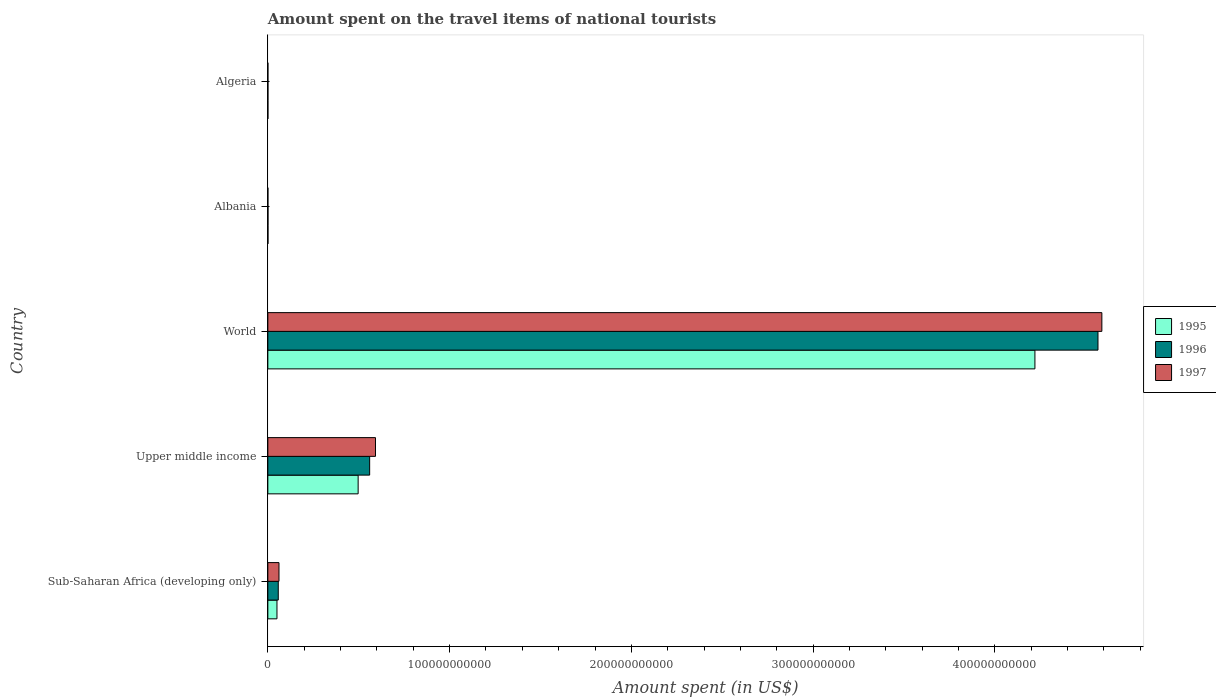How many groups of bars are there?
Provide a short and direct response. 5. Are the number of bars per tick equal to the number of legend labels?
Provide a short and direct response. Yes. What is the label of the 4th group of bars from the top?
Offer a very short reply. Upper middle income. What is the amount spent on the travel items of national tourists in 1995 in Sub-Saharan Africa (developing only)?
Provide a short and direct response. 5.02e+09. Across all countries, what is the maximum amount spent on the travel items of national tourists in 1996?
Make the answer very short. 4.57e+11. Across all countries, what is the minimum amount spent on the travel items of national tourists in 1997?
Make the answer very short. 2.70e+07. In which country was the amount spent on the travel items of national tourists in 1997 minimum?
Keep it short and to the point. Albania. What is the total amount spent on the travel items of national tourists in 1997 in the graph?
Ensure brevity in your answer.  5.24e+11. What is the difference between the amount spent on the travel items of national tourists in 1997 in Albania and that in Upper middle income?
Offer a very short reply. -5.92e+1. What is the difference between the amount spent on the travel items of national tourists in 1997 in Algeria and the amount spent on the travel items of national tourists in 1995 in Sub-Saharan Africa (developing only)?
Offer a very short reply. -4.99e+09. What is the average amount spent on the travel items of national tourists in 1997 per country?
Give a very brief answer. 1.05e+11. What is the difference between the amount spent on the travel items of national tourists in 1996 and amount spent on the travel items of national tourists in 1997 in Sub-Saharan Africa (developing only)?
Give a very brief answer. -4.02e+08. What is the ratio of the amount spent on the travel items of national tourists in 1996 in Algeria to that in Sub-Saharan Africa (developing only)?
Keep it short and to the point. 0.01. What is the difference between the highest and the second highest amount spent on the travel items of national tourists in 1995?
Your response must be concise. 3.72e+11. What is the difference between the highest and the lowest amount spent on the travel items of national tourists in 1996?
Make the answer very short. 4.57e+11. What does the 3rd bar from the top in Algeria represents?
Ensure brevity in your answer.  1995. Is it the case that in every country, the sum of the amount spent on the travel items of national tourists in 1997 and amount spent on the travel items of national tourists in 1996 is greater than the amount spent on the travel items of national tourists in 1995?
Give a very brief answer. Yes. How many bars are there?
Give a very brief answer. 15. Are all the bars in the graph horizontal?
Your answer should be very brief. Yes. How many countries are there in the graph?
Offer a terse response. 5. What is the difference between two consecutive major ticks on the X-axis?
Your answer should be compact. 1.00e+11. Are the values on the major ticks of X-axis written in scientific E-notation?
Ensure brevity in your answer.  No. Does the graph contain any zero values?
Your answer should be very brief. No. Does the graph contain grids?
Provide a short and direct response. No. How many legend labels are there?
Provide a short and direct response. 3. How are the legend labels stacked?
Your answer should be very brief. Vertical. What is the title of the graph?
Provide a succinct answer. Amount spent on the travel items of national tourists. Does "1995" appear as one of the legend labels in the graph?
Offer a very short reply. Yes. What is the label or title of the X-axis?
Your answer should be very brief. Amount spent (in US$). What is the label or title of the Y-axis?
Provide a succinct answer. Country. What is the Amount spent (in US$) of 1995 in Sub-Saharan Africa (developing only)?
Provide a short and direct response. 5.02e+09. What is the Amount spent (in US$) in 1996 in Sub-Saharan Africa (developing only)?
Give a very brief answer. 5.73e+09. What is the Amount spent (in US$) of 1997 in Sub-Saharan Africa (developing only)?
Your answer should be very brief. 6.13e+09. What is the Amount spent (in US$) in 1995 in Upper middle income?
Ensure brevity in your answer.  4.97e+1. What is the Amount spent (in US$) in 1996 in Upper middle income?
Ensure brevity in your answer.  5.60e+1. What is the Amount spent (in US$) of 1997 in Upper middle income?
Offer a very short reply. 5.92e+1. What is the Amount spent (in US$) in 1995 in World?
Provide a succinct answer. 4.22e+11. What is the Amount spent (in US$) in 1996 in World?
Make the answer very short. 4.57e+11. What is the Amount spent (in US$) of 1997 in World?
Provide a short and direct response. 4.59e+11. What is the Amount spent (in US$) in 1995 in Albania?
Provide a succinct answer. 6.50e+07. What is the Amount spent (in US$) of 1996 in Albania?
Your answer should be very brief. 7.70e+07. What is the Amount spent (in US$) in 1997 in Albania?
Offer a terse response. 2.70e+07. What is the Amount spent (in US$) of 1995 in Algeria?
Offer a terse response. 3.20e+07. What is the Amount spent (in US$) of 1996 in Algeria?
Provide a short and direct response. 4.50e+07. What is the Amount spent (in US$) in 1997 in Algeria?
Your response must be concise. 2.80e+07. Across all countries, what is the maximum Amount spent (in US$) of 1995?
Ensure brevity in your answer.  4.22e+11. Across all countries, what is the maximum Amount spent (in US$) of 1996?
Offer a very short reply. 4.57e+11. Across all countries, what is the maximum Amount spent (in US$) in 1997?
Make the answer very short. 4.59e+11. Across all countries, what is the minimum Amount spent (in US$) in 1995?
Offer a terse response. 3.20e+07. Across all countries, what is the minimum Amount spent (in US$) in 1996?
Ensure brevity in your answer.  4.50e+07. Across all countries, what is the minimum Amount spent (in US$) of 1997?
Keep it short and to the point. 2.70e+07. What is the total Amount spent (in US$) in 1995 in the graph?
Keep it short and to the point. 4.77e+11. What is the total Amount spent (in US$) in 1996 in the graph?
Provide a succinct answer. 5.19e+11. What is the total Amount spent (in US$) in 1997 in the graph?
Your response must be concise. 5.24e+11. What is the difference between the Amount spent (in US$) in 1995 in Sub-Saharan Africa (developing only) and that in Upper middle income?
Your answer should be compact. -4.47e+1. What is the difference between the Amount spent (in US$) of 1996 in Sub-Saharan Africa (developing only) and that in Upper middle income?
Provide a short and direct response. -5.03e+1. What is the difference between the Amount spent (in US$) in 1997 in Sub-Saharan Africa (developing only) and that in Upper middle income?
Give a very brief answer. -5.31e+1. What is the difference between the Amount spent (in US$) of 1995 in Sub-Saharan Africa (developing only) and that in World?
Give a very brief answer. -4.17e+11. What is the difference between the Amount spent (in US$) in 1996 in Sub-Saharan Africa (developing only) and that in World?
Offer a terse response. -4.51e+11. What is the difference between the Amount spent (in US$) in 1997 in Sub-Saharan Africa (developing only) and that in World?
Your answer should be compact. -4.53e+11. What is the difference between the Amount spent (in US$) of 1995 in Sub-Saharan Africa (developing only) and that in Albania?
Give a very brief answer. 4.95e+09. What is the difference between the Amount spent (in US$) of 1996 in Sub-Saharan Africa (developing only) and that in Albania?
Give a very brief answer. 5.65e+09. What is the difference between the Amount spent (in US$) of 1997 in Sub-Saharan Africa (developing only) and that in Albania?
Provide a short and direct response. 6.11e+09. What is the difference between the Amount spent (in US$) of 1995 in Sub-Saharan Africa (developing only) and that in Algeria?
Give a very brief answer. 4.99e+09. What is the difference between the Amount spent (in US$) of 1996 in Sub-Saharan Africa (developing only) and that in Algeria?
Provide a short and direct response. 5.69e+09. What is the difference between the Amount spent (in US$) in 1997 in Sub-Saharan Africa (developing only) and that in Algeria?
Give a very brief answer. 6.11e+09. What is the difference between the Amount spent (in US$) of 1995 in Upper middle income and that in World?
Offer a terse response. -3.72e+11. What is the difference between the Amount spent (in US$) of 1996 in Upper middle income and that in World?
Provide a succinct answer. -4.01e+11. What is the difference between the Amount spent (in US$) of 1997 in Upper middle income and that in World?
Keep it short and to the point. -4.00e+11. What is the difference between the Amount spent (in US$) in 1995 in Upper middle income and that in Albania?
Ensure brevity in your answer.  4.96e+1. What is the difference between the Amount spent (in US$) of 1996 in Upper middle income and that in Albania?
Offer a terse response. 5.59e+1. What is the difference between the Amount spent (in US$) in 1997 in Upper middle income and that in Albania?
Give a very brief answer. 5.92e+1. What is the difference between the Amount spent (in US$) in 1995 in Upper middle income and that in Algeria?
Your answer should be very brief. 4.97e+1. What is the difference between the Amount spent (in US$) in 1996 in Upper middle income and that in Algeria?
Your response must be concise. 5.60e+1. What is the difference between the Amount spent (in US$) of 1997 in Upper middle income and that in Algeria?
Ensure brevity in your answer.  5.92e+1. What is the difference between the Amount spent (in US$) of 1995 in World and that in Albania?
Your answer should be very brief. 4.22e+11. What is the difference between the Amount spent (in US$) in 1996 in World and that in Albania?
Your answer should be very brief. 4.57e+11. What is the difference between the Amount spent (in US$) of 1997 in World and that in Albania?
Your response must be concise. 4.59e+11. What is the difference between the Amount spent (in US$) of 1995 in World and that in Algeria?
Offer a terse response. 4.22e+11. What is the difference between the Amount spent (in US$) in 1996 in World and that in Algeria?
Keep it short and to the point. 4.57e+11. What is the difference between the Amount spent (in US$) of 1997 in World and that in Algeria?
Offer a very short reply. 4.59e+11. What is the difference between the Amount spent (in US$) in 1995 in Albania and that in Algeria?
Your answer should be very brief. 3.30e+07. What is the difference between the Amount spent (in US$) in 1996 in Albania and that in Algeria?
Provide a succinct answer. 3.20e+07. What is the difference between the Amount spent (in US$) of 1995 in Sub-Saharan Africa (developing only) and the Amount spent (in US$) of 1996 in Upper middle income?
Provide a succinct answer. -5.10e+1. What is the difference between the Amount spent (in US$) in 1995 in Sub-Saharan Africa (developing only) and the Amount spent (in US$) in 1997 in Upper middle income?
Make the answer very short. -5.42e+1. What is the difference between the Amount spent (in US$) in 1996 in Sub-Saharan Africa (developing only) and the Amount spent (in US$) in 1997 in Upper middle income?
Your answer should be very brief. -5.35e+1. What is the difference between the Amount spent (in US$) in 1995 in Sub-Saharan Africa (developing only) and the Amount spent (in US$) in 1996 in World?
Provide a succinct answer. -4.52e+11. What is the difference between the Amount spent (in US$) in 1995 in Sub-Saharan Africa (developing only) and the Amount spent (in US$) in 1997 in World?
Give a very brief answer. -4.54e+11. What is the difference between the Amount spent (in US$) in 1996 in Sub-Saharan Africa (developing only) and the Amount spent (in US$) in 1997 in World?
Keep it short and to the point. -4.53e+11. What is the difference between the Amount spent (in US$) in 1995 in Sub-Saharan Africa (developing only) and the Amount spent (in US$) in 1996 in Albania?
Make the answer very short. 4.94e+09. What is the difference between the Amount spent (in US$) of 1995 in Sub-Saharan Africa (developing only) and the Amount spent (in US$) of 1997 in Albania?
Offer a terse response. 4.99e+09. What is the difference between the Amount spent (in US$) in 1996 in Sub-Saharan Africa (developing only) and the Amount spent (in US$) in 1997 in Albania?
Your response must be concise. 5.70e+09. What is the difference between the Amount spent (in US$) of 1995 in Sub-Saharan Africa (developing only) and the Amount spent (in US$) of 1996 in Algeria?
Your answer should be very brief. 4.97e+09. What is the difference between the Amount spent (in US$) in 1995 in Sub-Saharan Africa (developing only) and the Amount spent (in US$) in 1997 in Algeria?
Give a very brief answer. 4.99e+09. What is the difference between the Amount spent (in US$) of 1996 in Sub-Saharan Africa (developing only) and the Amount spent (in US$) of 1997 in Algeria?
Your answer should be compact. 5.70e+09. What is the difference between the Amount spent (in US$) of 1995 in Upper middle income and the Amount spent (in US$) of 1996 in World?
Ensure brevity in your answer.  -4.07e+11. What is the difference between the Amount spent (in US$) of 1995 in Upper middle income and the Amount spent (in US$) of 1997 in World?
Ensure brevity in your answer.  -4.09e+11. What is the difference between the Amount spent (in US$) of 1996 in Upper middle income and the Amount spent (in US$) of 1997 in World?
Provide a succinct answer. -4.03e+11. What is the difference between the Amount spent (in US$) of 1995 in Upper middle income and the Amount spent (in US$) of 1996 in Albania?
Offer a terse response. 4.96e+1. What is the difference between the Amount spent (in US$) of 1995 in Upper middle income and the Amount spent (in US$) of 1997 in Albania?
Provide a short and direct response. 4.97e+1. What is the difference between the Amount spent (in US$) of 1996 in Upper middle income and the Amount spent (in US$) of 1997 in Albania?
Give a very brief answer. 5.60e+1. What is the difference between the Amount spent (in US$) of 1995 in Upper middle income and the Amount spent (in US$) of 1996 in Algeria?
Provide a succinct answer. 4.96e+1. What is the difference between the Amount spent (in US$) of 1995 in Upper middle income and the Amount spent (in US$) of 1997 in Algeria?
Your answer should be very brief. 4.97e+1. What is the difference between the Amount spent (in US$) in 1996 in Upper middle income and the Amount spent (in US$) in 1997 in Algeria?
Provide a short and direct response. 5.60e+1. What is the difference between the Amount spent (in US$) of 1995 in World and the Amount spent (in US$) of 1996 in Albania?
Make the answer very short. 4.22e+11. What is the difference between the Amount spent (in US$) of 1995 in World and the Amount spent (in US$) of 1997 in Albania?
Ensure brevity in your answer.  4.22e+11. What is the difference between the Amount spent (in US$) of 1996 in World and the Amount spent (in US$) of 1997 in Albania?
Provide a short and direct response. 4.57e+11. What is the difference between the Amount spent (in US$) of 1995 in World and the Amount spent (in US$) of 1996 in Algeria?
Provide a succinct answer. 4.22e+11. What is the difference between the Amount spent (in US$) of 1995 in World and the Amount spent (in US$) of 1997 in Algeria?
Ensure brevity in your answer.  4.22e+11. What is the difference between the Amount spent (in US$) of 1996 in World and the Amount spent (in US$) of 1997 in Algeria?
Your answer should be very brief. 4.57e+11. What is the difference between the Amount spent (in US$) of 1995 in Albania and the Amount spent (in US$) of 1997 in Algeria?
Offer a very short reply. 3.70e+07. What is the difference between the Amount spent (in US$) of 1996 in Albania and the Amount spent (in US$) of 1997 in Algeria?
Offer a very short reply. 4.90e+07. What is the average Amount spent (in US$) of 1995 per country?
Offer a terse response. 9.54e+1. What is the average Amount spent (in US$) in 1996 per country?
Your answer should be compact. 1.04e+11. What is the average Amount spent (in US$) of 1997 per country?
Provide a short and direct response. 1.05e+11. What is the difference between the Amount spent (in US$) in 1995 and Amount spent (in US$) in 1996 in Sub-Saharan Africa (developing only)?
Provide a succinct answer. -7.13e+08. What is the difference between the Amount spent (in US$) in 1995 and Amount spent (in US$) in 1997 in Sub-Saharan Africa (developing only)?
Offer a very short reply. -1.11e+09. What is the difference between the Amount spent (in US$) in 1996 and Amount spent (in US$) in 1997 in Sub-Saharan Africa (developing only)?
Your answer should be compact. -4.02e+08. What is the difference between the Amount spent (in US$) of 1995 and Amount spent (in US$) of 1996 in Upper middle income?
Make the answer very short. -6.33e+09. What is the difference between the Amount spent (in US$) in 1995 and Amount spent (in US$) in 1997 in Upper middle income?
Offer a very short reply. -9.54e+09. What is the difference between the Amount spent (in US$) of 1996 and Amount spent (in US$) of 1997 in Upper middle income?
Offer a terse response. -3.21e+09. What is the difference between the Amount spent (in US$) in 1995 and Amount spent (in US$) in 1996 in World?
Your answer should be compact. -3.47e+1. What is the difference between the Amount spent (in US$) in 1995 and Amount spent (in US$) in 1997 in World?
Provide a succinct answer. -3.68e+1. What is the difference between the Amount spent (in US$) in 1996 and Amount spent (in US$) in 1997 in World?
Provide a succinct answer. -2.13e+09. What is the difference between the Amount spent (in US$) of 1995 and Amount spent (in US$) of 1996 in Albania?
Ensure brevity in your answer.  -1.20e+07. What is the difference between the Amount spent (in US$) of 1995 and Amount spent (in US$) of 1997 in Albania?
Keep it short and to the point. 3.80e+07. What is the difference between the Amount spent (in US$) of 1996 and Amount spent (in US$) of 1997 in Albania?
Your answer should be compact. 5.00e+07. What is the difference between the Amount spent (in US$) of 1995 and Amount spent (in US$) of 1996 in Algeria?
Provide a short and direct response. -1.30e+07. What is the difference between the Amount spent (in US$) of 1996 and Amount spent (in US$) of 1997 in Algeria?
Your answer should be very brief. 1.70e+07. What is the ratio of the Amount spent (in US$) in 1995 in Sub-Saharan Africa (developing only) to that in Upper middle income?
Offer a very short reply. 0.1. What is the ratio of the Amount spent (in US$) in 1996 in Sub-Saharan Africa (developing only) to that in Upper middle income?
Ensure brevity in your answer.  0.1. What is the ratio of the Amount spent (in US$) of 1997 in Sub-Saharan Africa (developing only) to that in Upper middle income?
Offer a terse response. 0.1. What is the ratio of the Amount spent (in US$) of 1995 in Sub-Saharan Africa (developing only) to that in World?
Give a very brief answer. 0.01. What is the ratio of the Amount spent (in US$) of 1996 in Sub-Saharan Africa (developing only) to that in World?
Ensure brevity in your answer.  0.01. What is the ratio of the Amount spent (in US$) in 1997 in Sub-Saharan Africa (developing only) to that in World?
Offer a very short reply. 0.01. What is the ratio of the Amount spent (in US$) in 1995 in Sub-Saharan Africa (developing only) to that in Albania?
Give a very brief answer. 77.21. What is the ratio of the Amount spent (in US$) in 1996 in Sub-Saharan Africa (developing only) to that in Albania?
Your answer should be very brief. 74.43. What is the ratio of the Amount spent (in US$) of 1997 in Sub-Saharan Africa (developing only) to that in Albania?
Offer a very short reply. 227.15. What is the ratio of the Amount spent (in US$) in 1995 in Sub-Saharan Africa (developing only) to that in Algeria?
Ensure brevity in your answer.  156.82. What is the ratio of the Amount spent (in US$) of 1996 in Sub-Saharan Africa (developing only) to that in Algeria?
Your answer should be compact. 127.36. What is the ratio of the Amount spent (in US$) in 1997 in Sub-Saharan Africa (developing only) to that in Algeria?
Offer a very short reply. 219.04. What is the ratio of the Amount spent (in US$) of 1995 in Upper middle income to that in World?
Offer a terse response. 0.12. What is the ratio of the Amount spent (in US$) of 1996 in Upper middle income to that in World?
Make the answer very short. 0.12. What is the ratio of the Amount spent (in US$) of 1997 in Upper middle income to that in World?
Ensure brevity in your answer.  0.13. What is the ratio of the Amount spent (in US$) in 1995 in Upper middle income to that in Albania?
Offer a very short reply. 764.39. What is the ratio of the Amount spent (in US$) in 1996 in Upper middle income to that in Albania?
Give a very brief answer. 727.52. What is the ratio of the Amount spent (in US$) in 1997 in Upper middle income to that in Albania?
Offer a very short reply. 2193.5. What is the ratio of the Amount spent (in US$) in 1995 in Upper middle income to that in Algeria?
Make the answer very short. 1552.66. What is the ratio of the Amount spent (in US$) of 1996 in Upper middle income to that in Algeria?
Provide a short and direct response. 1244.88. What is the ratio of the Amount spent (in US$) in 1997 in Upper middle income to that in Algeria?
Ensure brevity in your answer.  2115.16. What is the ratio of the Amount spent (in US$) of 1995 in World to that in Albania?
Offer a terse response. 6493.1. What is the ratio of the Amount spent (in US$) of 1996 in World to that in Albania?
Keep it short and to the point. 5931.82. What is the ratio of the Amount spent (in US$) of 1997 in World to that in Albania?
Your answer should be compact. 1.70e+04. What is the ratio of the Amount spent (in US$) in 1995 in World to that in Algeria?
Your answer should be compact. 1.32e+04. What is the ratio of the Amount spent (in US$) of 1996 in World to that in Algeria?
Make the answer very short. 1.02e+04. What is the ratio of the Amount spent (in US$) in 1997 in World to that in Algeria?
Make the answer very short. 1.64e+04. What is the ratio of the Amount spent (in US$) of 1995 in Albania to that in Algeria?
Your response must be concise. 2.03. What is the ratio of the Amount spent (in US$) of 1996 in Albania to that in Algeria?
Ensure brevity in your answer.  1.71. What is the difference between the highest and the second highest Amount spent (in US$) of 1995?
Provide a succinct answer. 3.72e+11. What is the difference between the highest and the second highest Amount spent (in US$) of 1996?
Offer a terse response. 4.01e+11. What is the difference between the highest and the second highest Amount spent (in US$) in 1997?
Offer a very short reply. 4.00e+11. What is the difference between the highest and the lowest Amount spent (in US$) in 1995?
Your response must be concise. 4.22e+11. What is the difference between the highest and the lowest Amount spent (in US$) of 1996?
Offer a very short reply. 4.57e+11. What is the difference between the highest and the lowest Amount spent (in US$) of 1997?
Give a very brief answer. 4.59e+11. 